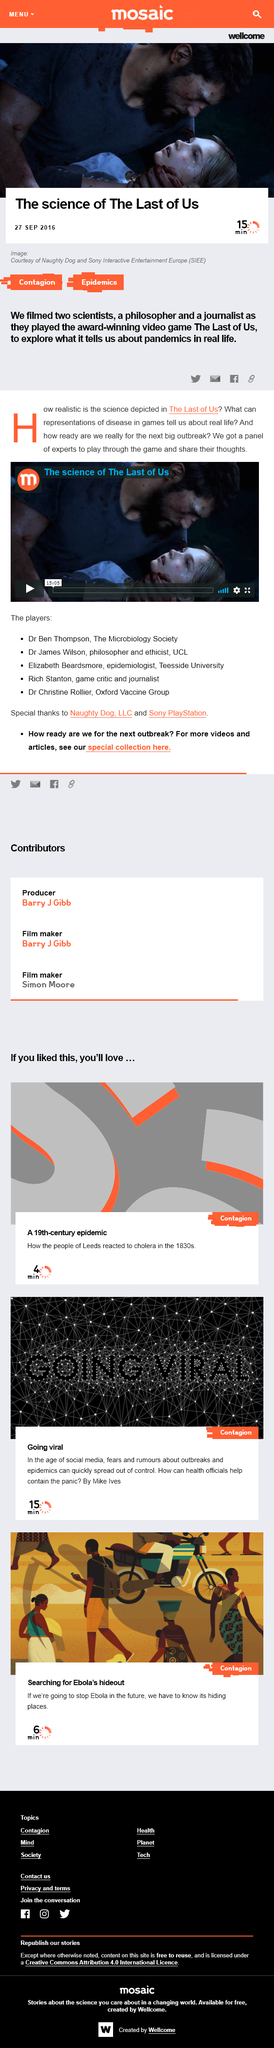Identify some key points in this picture. This article was published on September 27th, 2016. The video in this article is 15 minutes and 5 seconds long, as declared in the text. This article will take approximately 15 minutes to read. 